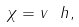Convert formula to latex. <formula><loc_0><loc_0><loc_500><loc_500>\chi = v \ h ,</formula> 